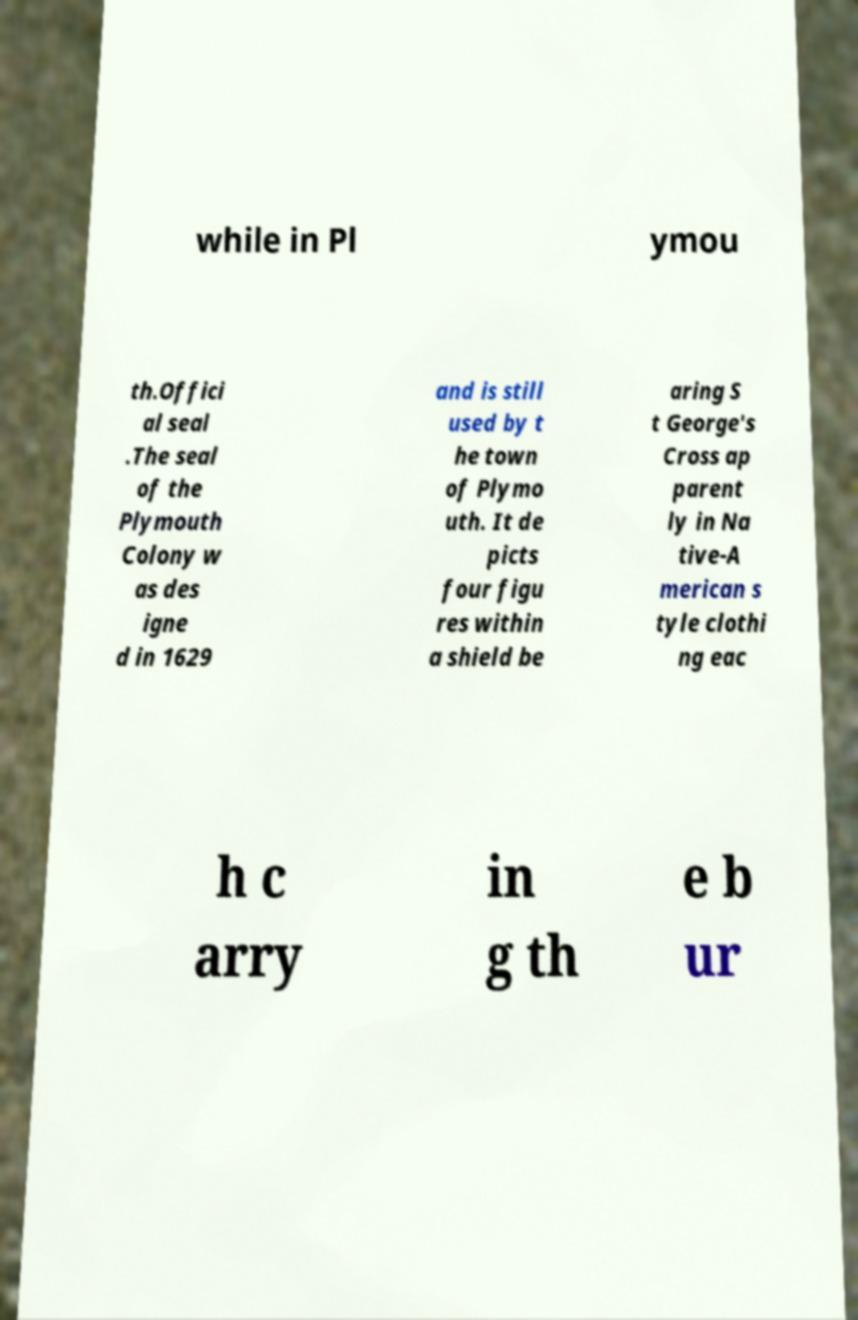Can you accurately transcribe the text from the provided image for me? while in Pl ymou th.Offici al seal .The seal of the Plymouth Colony w as des igne d in 1629 and is still used by t he town of Plymo uth. It de picts four figu res within a shield be aring S t George's Cross ap parent ly in Na tive-A merican s tyle clothi ng eac h c arry in g th e b ur 